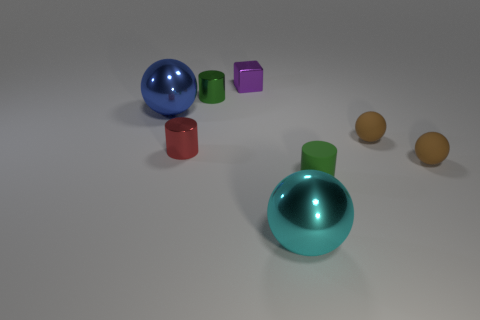There is a blue metal thing left of the large cyan shiny sphere; does it have the same size as the shiny thing behind the green metallic object?
Your answer should be compact. No. The small matte cylinder is what color?
Make the answer very short. Green. Do the brown rubber thing that is behind the small red shiny cylinder and the tiny purple metallic object have the same shape?
Provide a short and direct response. No. There is a purple thing that is the same size as the green rubber cylinder; what is its shape?
Provide a succinct answer. Cube. Are there any small shiny cylinders of the same color as the tiny rubber cylinder?
Give a very brief answer. Yes. There is a tiny matte cylinder; is its color the same as the tiny metallic cylinder behind the red shiny cylinder?
Offer a terse response. Yes. There is a big metal ball that is right of the large ball that is to the left of the purple object; what color is it?
Provide a succinct answer. Cyan. There is a shiny ball that is in front of the blue metallic object that is to the left of the purple thing; are there any shiny balls left of it?
Make the answer very short. Yes. There is a block that is made of the same material as the tiny red cylinder; what is its color?
Make the answer very short. Purple. What number of small red things have the same material as the small red cylinder?
Your answer should be compact. 0. 